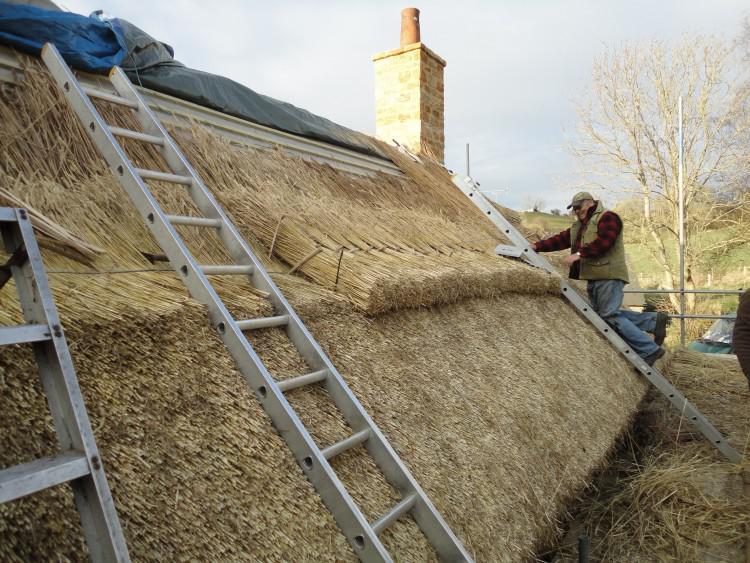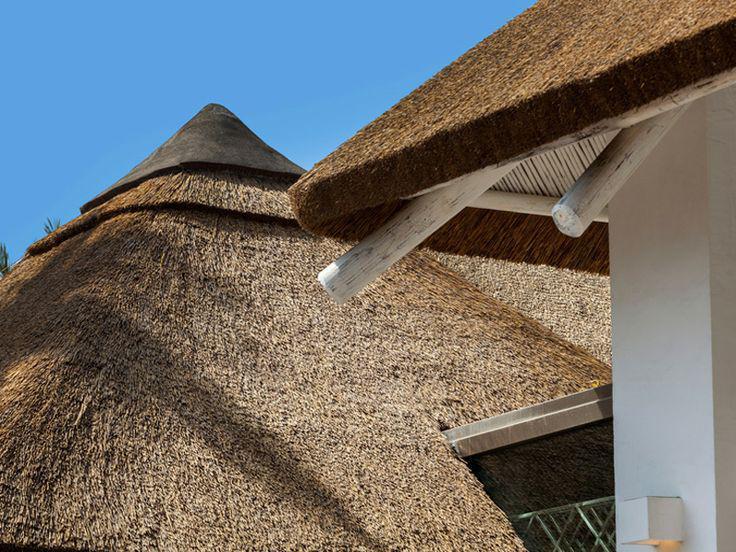The first image is the image on the left, the second image is the image on the right. Evaluate the accuracy of this statement regarding the images: "There is at least one aluminum ladder leaning against a thatched roof.". Is it true? Answer yes or no. Yes. The first image is the image on the left, the second image is the image on the right. Considering the images on both sides, is "A man is standing on the roof in one of the images." valid? Answer yes or no. Yes. 